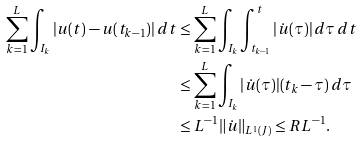<formula> <loc_0><loc_0><loc_500><loc_500>\sum _ { k = 1 } ^ { L } \int _ { I _ { k } } | u ( t ) - u ( t _ { k - 1 } ) | \, d t & \leq \sum _ { k = 1 } ^ { L } \int _ { I _ { k } } \int _ { t _ { k - 1 } } ^ { t } | \dot { u } ( \tau ) | \, d \tau \, d t \\ & \leq \sum _ { k = 1 } ^ { L } \int _ { I _ { k } } | \dot { u } ( \tau ) | ( t _ { k } - \tau ) \, d \tau \\ & \leq L ^ { - 1 } \| \dot { u } \| _ { L ^ { 1 } ( J ) } \leq R L ^ { - 1 } .</formula> 